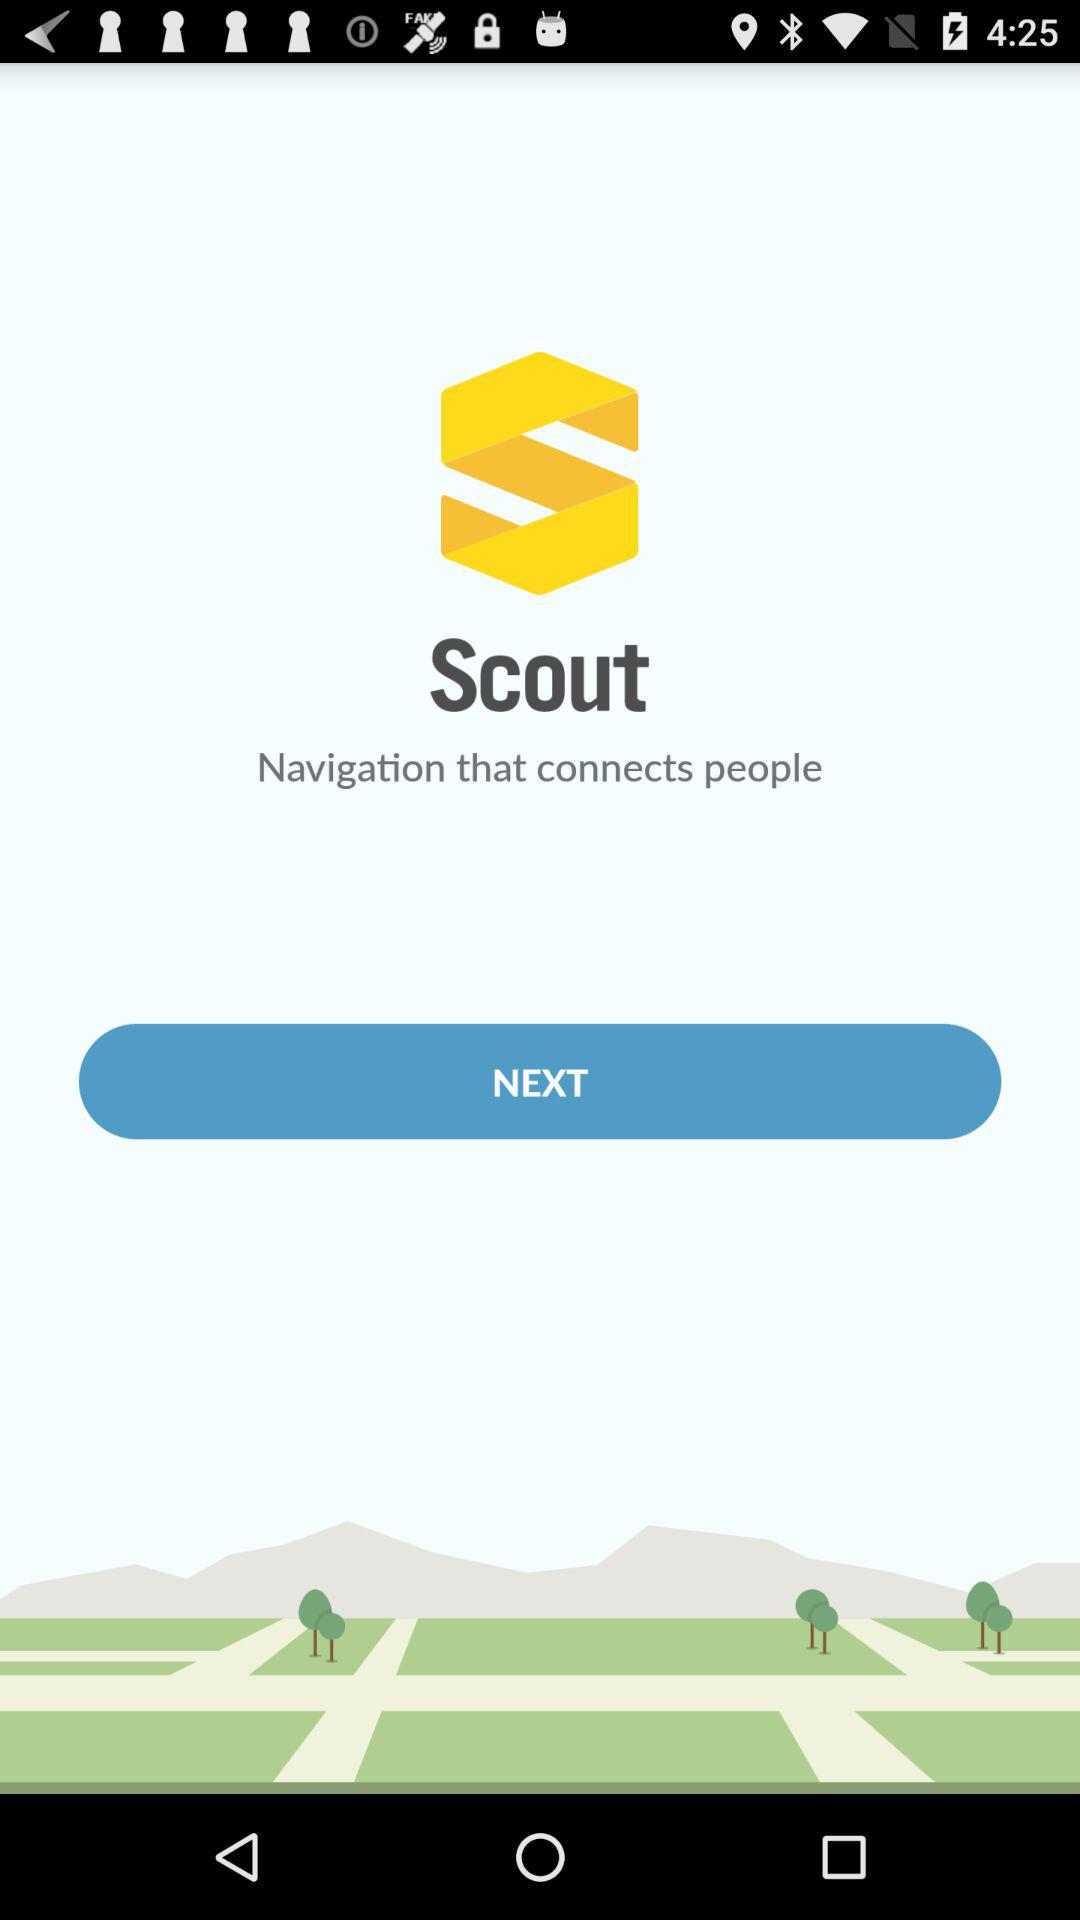What is the name of the application? The name of the application is "Scout". 